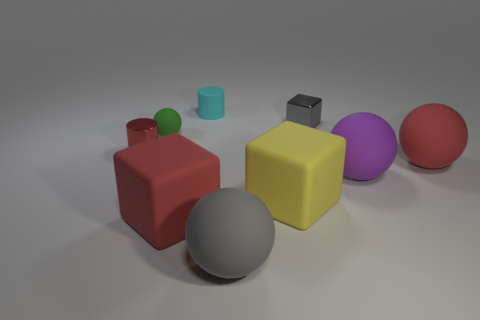Subtract all tiny balls. How many balls are left? 3 Subtract all red spheres. How many spheres are left? 3 Add 2 tiny cyan cylinders. How many tiny cyan cylinders exist? 3 Add 1 purple rubber objects. How many objects exist? 10 Subtract 0 cyan blocks. How many objects are left? 9 Subtract all cylinders. How many objects are left? 7 Subtract 2 blocks. How many blocks are left? 1 Subtract all gray spheres. Subtract all blue cylinders. How many spheres are left? 3 Subtract all green balls. How many green blocks are left? 0 Subtract all tiny matte cylinders. Subtract all large blocks. How many objects are left? 6 